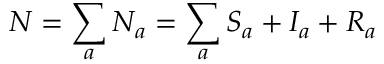Convert formula to latex. <formula><loc_0><loc_0><loc_500><loc_500>N = \sum _ { a } N _ { a } = \sum _ { a } S _ { a } + I _ { a } + R _ { a }</formula> 